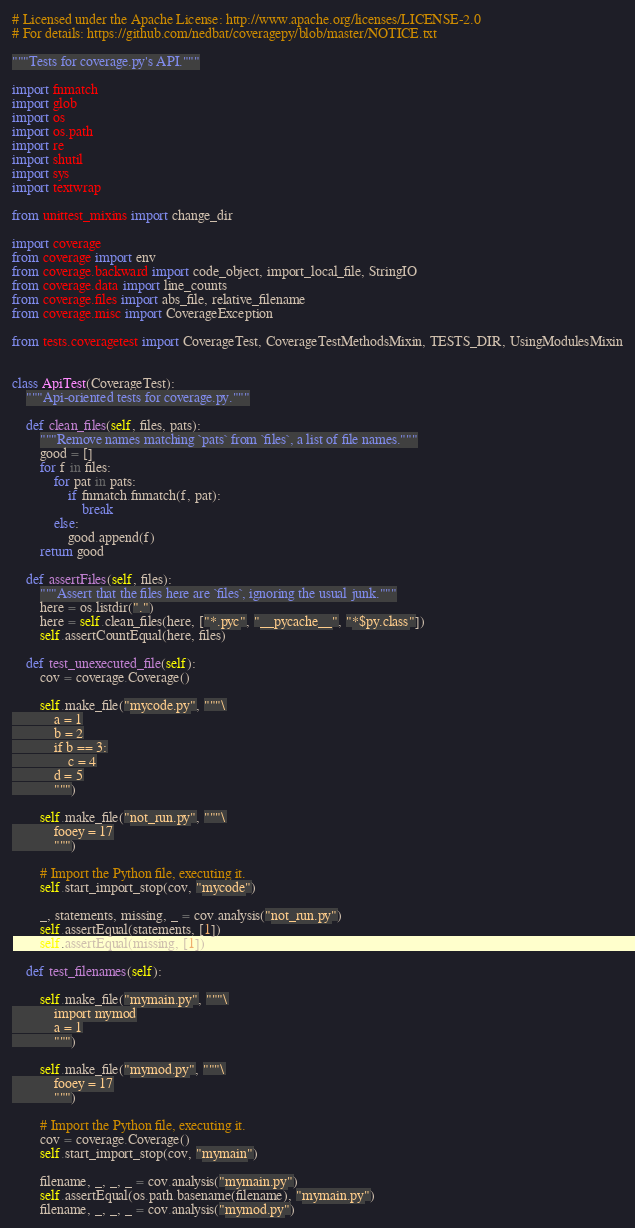Convert code to text. <code><loc_0><loc_0><loc_500><loc_500><_Python_># Licensed under the Apache License: http://www.apache.org/licenses/LICENSE-2.0
# For details: https://github.com/nedbat/coveragepy/blob/master/NOTICE.txt

"""Tests for coverage.py's API."""

import fnmatch
import glob
import os
import os.path
import re
import shutil
import sys
import textwrap

from unittest_mixins import change_dir

import coverage
from coverage import env
from coverage.backward import code_object, import_local_file, StringIO
from coverage.data import line_counts
from coverage.files import abs_file, relative_filename
from coverage.misc import CoverageException

from tests.coveragetest import CoverageTest, CoverageTestMethodsMixin, TESTS_DIR, UsingModulesMixin


class ApiTest(CoverageTest):
    """Api-oriented tests for coverage.py."""

    def clean_files(self, files, pats):
        """Remove names matching `pats` from `files`, a list of file names."""
        good = []
        for f in files:
            for pat in pats:
                if fnmatch.fnmatch(f, pat):
                    break
            else:
                good.append(f)
        return good

    def assertFiles(self, files):
        """Assert that the files here are `files`, ignoring the usual junk."""
        here = os.listdir(".")
        here = self.clean_files(here, ["*.pyc", "__pycache__", "*$py.class"])
        self.assertCountEqual(here, files)

    def test_unexecuted_file(self):
        cov = coverage.Coverage()

        self.make_file("mycode.py", """\
            a = 1
            b = 2
            if b == 3:
                c = 4
            d = 5
            """)

        self.make_file("not_run.py", """\
            fooey = 17
            """)

        # Import the Python file, executing it.
        self.start_import_stop(cov, "mycode")

        _, statements, missing, _ = cov.analysis("not_run.py")
        self.assertEqual(statements, [1])
        self.assertEqual(missing, [1])

    def test_filenames(self):

        self.make_file("mymain.py", """\
            import mymod
            a = 1
            """)

        self.make_file("mymod.py", """\
            fooey = 17
            """)

        # Import the Python file, executing it.
        cov = coverage.Coverage()
        self.start_import_stop(cov, "mymain")

        filename, _, _, _ = cov.analysis("mymain.py")
        self.assertEqual(os.path.basename(filename), "mymain.py")
        filename, _, _, _ = cov.analysis("mymod.py")</code> 